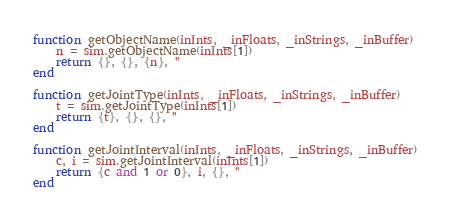Convert code to text. <code><loc_0><loc_0><loc_500><loc_500><_Lua_>function getObjectName(inInts, _inFloats, _inStrings, _inBuffer)
	n = sim.getObjectName(inInts[1])
	return {}, {}, {n}, ''
end

function getJointType(inInts, _inFloats, _inStrings, _inBuffer)
	t = sim.getJointType(inInts[1])
	return {t}, {}, {}, ''
end

function getJointInterval(inInts, _inFloats, _inStrings, _inBuffer)
	c, i = sim.getJointInterval(inInts[1])
	return {c and 1 or 0}, i, {}, ''
end
</code> 